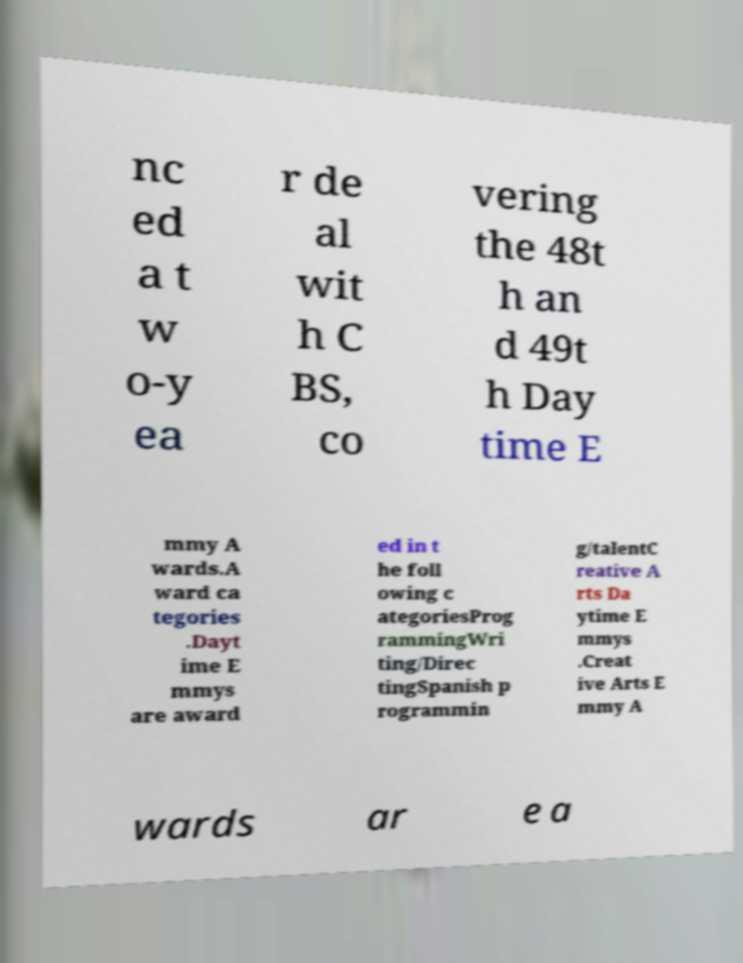Can you accurately transcribe the text from the provided image for me? nc ed a t w o-y ea r de al wit h C BS, co vering the 48t h an d 49t h Day time E mmy A wards.A ward ca tegories .Dayt ime E mmys are award ed in t he foll owing c ategoriesProg rammingWri ting/Direc tingSpanish p rogrammin g/talentC reative A rts Da ytime E mmys .Creat ive Arts E mmy A wards ar e a 